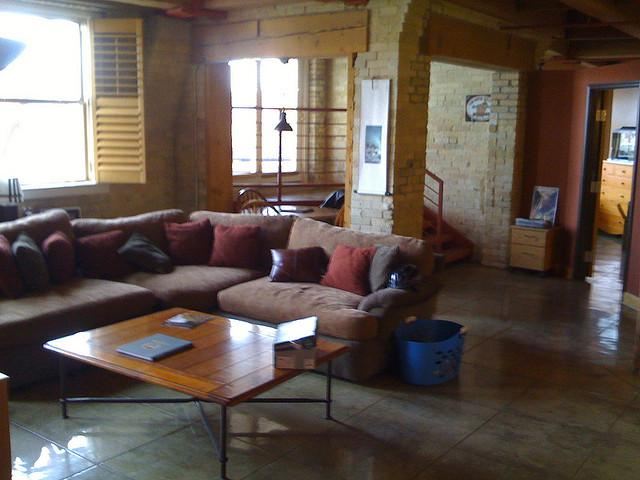What is on the table?

Choices:
A) ash tray
B) flowers
C) book
D) dog book 